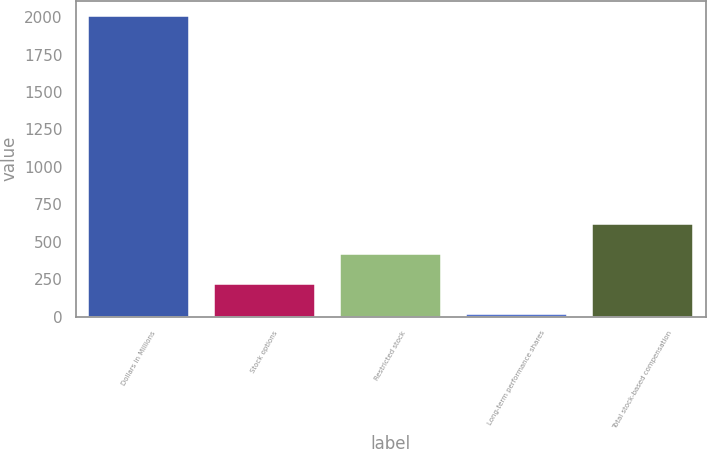<chart> <loc_0><loc_0><loc_500><loc_500><bar_chart><fcel>Dollars in Millions<fcel>Stock options<fcel>Restricted stock<fcel>Long-term performance shares<fcel>Total stock-based compensation<nl><fcel>2008<fcel>218.8<fcel>417.6<fcel>20<fcel>616.4<nl></chart> 